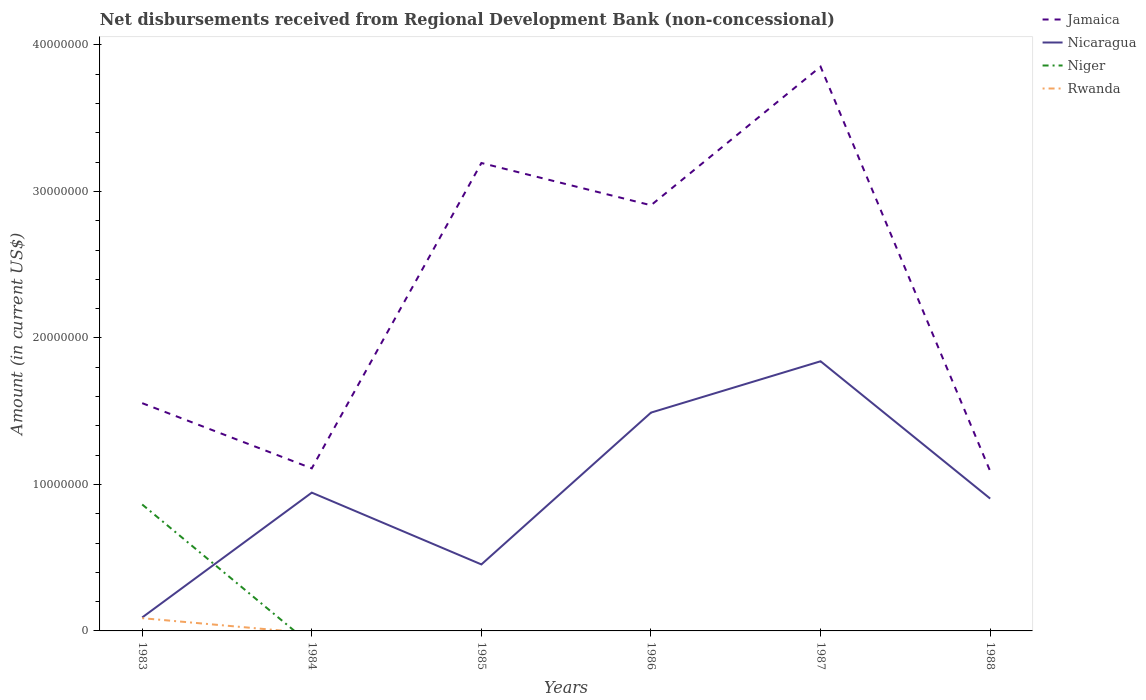Does the line corresponding to Nicaragua intersect with the line corresponding to Rwanda?
Offer a very short reply. No. Across all years, what is the maximum amount of disbursements received from Regional Development Bank in Rwanda?
Provide a succinct answer. 0. What is the total amount of disbursements received from Regional Development Bank in Jamaica in the graph?
Your answer should be compact. -1.35e+07. What is the difference between the highest and the second highest amount of disbursements received from Regional Development Bank in Rwanda?
Give a very brief answer. 8.70e+05. Is the amount of disbursements received from Regional Development Bank in Niger strictly greater than the amount of disbursements received from Regional Development Bank in Nicaragua over the years?
Your answer should be very brief. No. How many lines are there?
Ensure brevity in your answer.  4. Does the graph contain any zero values?
Provide a succinct answer. Yes. Does the graph contain grids?
Your answer should be compact. No. Where does the legend appear in the graph?
Ensure brevity in your answer.  Top right. How are the legend labels stacked?
Offer a terse response. Vertical. What is the title of the graph?
Offer a very short reply. Net disbursements received from Regional Development Bank (non-concessional). Does "Thailand" appear as one of the legend labels in the graph?
Give a very brief answer. No. What is the label or title of the X-axis?
Make the answer very short. Years. What is the label or title of the Y-axis?
Provide a succinct answer. Amount (in current US$). What is the Amount (in current US$) in Jamaica in 1983?
Provide a short and direct response. 1.55e+07. What is the Amount (in current US$) of Nicaragua in 1983?
Offer a very short reply. 9.19e+05. What is the Amount (in current US$) of Niger in 1983?
Offer a very short reply. 8.63e+06. What is the Amount (in current US$) of Rwanda in 1983?
Ensure brevity in your answer.  8.70e+05. What is the Amount (in current US$) in Jamaica in 1984?
Give a very brief answer. 1.11e+07. What is the Amount (in current US$) in Nicaragua in 1984?
Your response must be concise. 9.44e+06. What is the Amount (in current US$) in Rwanda in 1984?
Ensure brevity in your answer.  0. What is the Amount (in current US$) in Jamaica in 1985?
Provide a succinct answer. 3.19e+07. What is the Amount (in current US$) in Nicaragua in 1985?
Your answer should be very brief. 4.54e+06. What is the Amount (in current US$) of Rwanda in 1985?
Provide a succinct answer. 0. What is the Amount (in current US$) of Jamaica in 1986?
Ensure brevity in your answer.  2.91e+07. What is the Amount (in current US$) of Nicaragua in 1986?
Make the answer very short. 1.49e+07. What is the Amount (in current US$) in Jamaica in 1987?
Provide a short and direct response. 3.85e+07. What is the Amount (in current US$) in Nicaragua in 1987?
Your answer should be very brief. 1.84e+07. What is the Amount (in current US$) of Niger in 1987?
Your response must be concise. 0. What is the Amount (in current US$) in Jamaica in 1988?
Offer a very short reply. 1.09e+07. What is the Amount (in current US$) of Nicaragua in 1988?
Your answer should be very brief. 9.03e+06. What is the Amount (in current US$) of Niger in 1988?
Your response must be concise. 0. What is the Amount (in current US$) in Rwanda in 1988?
Provide a short and direct response. 0. Across all years, what is the maximum Amount (in current US$) in Jamaica?
Provide a succinct answer. 3.85e+07. Across all years, what is the maximum Amount (in current US$) of Nicaragua?
Provide a short and direct response. 1.84e+07. Across all years, what is the maximum Amount (in current US$) of Niger?
Keep it short and to the point. 8.63e+06. Across all years, what is the maximum Amount (in current US$) in Rwanda?
Your answer should be very brief. 8.70e+05. Across all years, what is the minimum Amount (in current US$) of Jamaica?
Offer a very short reply. 1.09e+07. Across all years, what is the minimum Amount (in current US$) of Nicaragua?
Offer a terse response. 9.19e+05. Across all years, what is the minimum Amount (in current US$) of Rwanda?
Provide a succinct answer. 0. What is the total Amount (in current US$) in Jamaica in the graph?
Offer a terse response. 1.37e+08. What is the total Amount (in current US$) of Nicaragua in the graph?
Your answer should be very brief. 5.72e+07. What is the total Amount (in current US$) of Niger in the graph?
Offer a terse response. 8.63e+06. What is the total Amount (in current US$) in Rwanda in the graph?
Your response must be concise. 8.70e+05. What is the difference between the Amount (in current US$) of Jamaica in 1983 and that in 1984?
Provide a succinct answer. 4.45e+06. What is the difference between the Amount (in current US$) in Nicaragua in 1983 and that in 1984?
Offer a very short reply. -8.52e+06. What is the difference between the Amount (in current US$) of Jamaica in 1983 and that in 1985?
Make the answer very short. -1.64e+07. What is the difference between the Amount (in current US$) of Nicaragua in 1983 and that in 1985?
Provide a short and direct response. -3.62e+06. What is the difference between the Amount (in current US$) in Jamaica in 1983 and that in 1986?
Give a very brief answer. -1.35e+07. What is the difference between the Amount (in current US$) in Nicaragua in 1983 and that in 1986?
Ensure brevity in your answer.  -1.40e+07. What is the difference between the Amount (in current US$) in Jamaica in 1983 and that in 1987?
Offer a very short reply. -2.30e+07. What is the difference between the Amount (in current US$) of Nicaragua in 1983 and that in 1987?
Your answer should be very brief. -1.75e+07. What is the difference between the Amount (in current US$) in Jamaica in 1983 and that in 1988?
Offer a terse response. 4.64e+06. What is the difference between the Amount (in current US$) in Nicaragua in 1983 and that in 1988?
Your answer should be compact. -8.11e+06. What is the difference between the Amount (in current US$) in Jamaica in 1984 and that in 1985?
Give a very brief answer. -2.08e+07. What is the difference between the Amount (in current US$) in Nicaragua in 1984 and that in 1985?
Your response must be concise. 4.90e+06. What is the difference between the Amount (in current US$) of Jamaica in 1984 and that in 1986?
Provide a short and direct response. -1.80e+07. What is the difference between the Amount (in current US$) of Nicaragua in 1984 and that in 1986?
Keep it short and to the point. -5.46e+06. What is the difference between the Amount (in current US$) of Jamaica in 1984 and that in 1987?
Keep it short and to the point. -2.74e+07. What is the difference between the Amount (in current US$) of Nicaragua in 1984 and that in 1987?
Offer a terse response. -8.97e+06. What is the difference between the Amount (in current US$) in Jamaica in 1984 and that in 1988?
Your answer should be very brief. 1.94e+05. What is the difference between the Amount (in current US$) in Nicaragua in 1984 and that in 1988?
Provide a short and direct response. 4.07e+05. What is the difference between the Amount (in current US$) in Jamaica in 1985 and that in 1986?
Offer a terse response. 2.88e+06. What is the difference between the Amount (in current US$) in Nicaragua in 1985 and that in 1986?
Your answer should be very brief. -1.04e+07. What is the difference between the Amount (in current US$) in Jamaica in 1985 and that in 1987?
Make the answer very short. -6.58e+06. What is the difference between the Amount (in current US$) of Nicaragua in 1985 and that in 1987?
Give a very brief answer. -1.39e+07. What is the difference between the Amount (in current US$) in Jamaica in 1985 and that in 1988?
Provide a succinct answer. 2.10e+07. What is the difference between the Amount (in current US$) in Nicaragua in 1985 and that in 1988?
Offer a terse response. -4.49e+06. What is the difference between the Amount (in current US$) in Jamaica in 1986 and that in 1987?
Provide a short and direct response. -9.46e+06. What is the difference between the Amount (in current US$) in Nicaragua in 1986 and that in 1987?
Make the answer very short. -3.50e+06. What is the difference between the Amount (in current US$) in Jamaica in 1986 and that in 1988?
Give a very brief answer. 1.82e+07. What is the difference between the Amount (in current US$) in Nicaragua in 1986 and that in 1988?
Provide a succinct answer. 5.87e+06. What is the difference between the Amount (in current US$) in Jamaica in 1987 and that in 1988?
Your response must be concise. 2.76e+07. What is the difference between the Amount (in current US$) in Nicaragua in 1987 and that in 1988?
Offer a very short reply. 9.37e+06. What is the difference between the Amount (in current US$) in Jamaica in 1983 and the Amount (in current US$) in Nicaragua in 1984?
Provide a succinct answer. 6.11e+06. What is the difference between the Amount (in current US$) of Jamaica in 1983 and the Amount (in current US$) of Nicaragua in 1985?
Offer a terse response. 1.10e+07. What is the difference between the Amount (in current US$) in Jamaica in 1983 and the Amount (in current US$) in Nicaragua in 1986?
Keep it short and to the point. 6.45e+05. What is the difference between the Amount (in current US$) in Jamaica in 1983 and the Amount (in current US$) in Nicaragua in 1987?
Ensure brevity in your answer.  -2.86e+06. What is the difference between the Amount (in current US$) of Jamaica in 1983 and the Amount (in current US$) of Nicaragua in 1988?
Your response must be concise. 6.51e+06. What is the difference between the Amount (in current US$) in Jamaica in 1984 and the Amount (in current US$) in Nicaragua in 1985?
Offer a terse response. 6.56e+06. What is the difference between the Amount (in current US$) in Jamaica in 1984 and the Amount (in current US$) in Nicaragua in 1986?
Offer a terse response. -3.80e+06. What is the difference between the Amount (in current US$) in Jamaica in 1984 and the Amount (in current US$) in Nicaragua in 1987?
Your answer should be compact. -7.31e+06. What is the difference between the Amount (in current US$) in Jamaica in 1984 and the Amount (in current US$) in Nicaragua in 1988?
Your response must be concise. 2.06e+06. What is the difference between the Amount (in current US$) of Jamaica in 1985 and the Amount (in current US$) of Nicaragua in 1986?
Make the answer very short. 1.70e+07. What is the difference between the Amount (in current US$) of Jamaica in 1985 and the Amount (in current US$) of Nicaragua in 1987?
Keep it short and to the point. 1.35e+07. What is the difference between the Amount (in current US$) in Jamaica in 1985 and the Amount (in current US$) in Nicaragua in 1988?
Give a very brief answer. 2.29e+07. What is the difference between the Amount (in current US$) of Jamaica in 1986 and the Amount (in current US$) of Nicaragua in 1987?
Your response must be concise. 1.06e+07. What is the difference between the Amount (in current US$) in Jamaica in 1986 and the Amount (in current US$) in Nicaragua in 1988?
Your answer should be very brief. 2.00e+07. What is the difference between the Amount (in current US$) in Jamaica in 1987 and the Amount (in current US$) in Nicaragua in 1988?
Provide a succinct answer. 2.95e+07. What is the average Amount (in current US$) in Jamaica per year?
Provide a succinct answer. 2.28e+07. What is the average Amount (in current US$) in Nicaragua per year?
Your response must be concise. 9.54e+06. What is the average Amount (in current US$) of Niger per year?
Provide a short and direct response. 1.44e+06. What is the average Amount (in current US$) in Rwanda per year?
Provide a short and direct response. 1.45e+05. In the year 1983, what is the difference between the Amount (in current US$) of Jamaica and Amount (in current US$) of Nicaragua?
Your answer should be very brief. 1.46e+07. In the year 1983, what is the difference between the Amount (in current US$) of Jamaica and Amount (in current US$) of Niger?
Give a very brief answer. 6.92e+06. In the year 1983, what is the difference between the Amount (in current US$) in Jamaica and Amount (in current US$) in Rwanda?
Your answer should be very brief. 1.47e+07. In the year 1983, what is the difference between the Amount (in current US$) in Nicaragua and Amount (in current US$) in Niger?
Provide a short and direct response. -7.71e+06. In the year 1983, what is the difference between the Amount (in current US$) in Nicaragua and Amount (in current US$) in Rwanda?
Your answer should be compact. 4.90e+04. In the year 1983, what is the difference between the Amount (in current US$) in Niger and Amount (in current US$) in Rwanda?
Keep it short and to the point. 7.76e+06. In the year 1984, what is the difference between the Amount (in current US$) in Jamaica and Amount (in current US$) in Nicaragua?
Provide a succinct answer. 1.66e+06. In the year 1985, what is the difference between the Amount (in current US$) of Jamaica and Amount (in current US$) of Nicaragua?
Your response must be concise. 2.74e+07. In the year 1986, what is the difference between the Amount (in current US$) of Jamaica and Amount (in current US$) of Nicaragua?
Offer a terse response. 1.42e+07. In the year 1987, what is the difference between the Amount (in current US$) of Jamaica and Amount (in current US$) of Nicaragua?
Provide a short and direct response. 2.01e+07. In the year 1988, what is the difference between the Amount (in current US$) of Jamaica and Amount (in current US$) of Nicaragua?
Keep it short and to the point. 1.87e+06. What is the ratio of the Amount (in current US$) in Jamaica in 1983 to that in 1984?
Offer a terse response. 1.4. What is the ratio of the Amount (in current US$) of Nicaragua in 1983 to that in 1984?
Keep it short and to the point. 0.1. What is the ratio of the Amount (in current US$) of Jamaica in 1983 to that in 1985?
Your answer should be compact. 0.49. What is the ratio of the Amount (in current US$) of Nicaragua in 1983 to that in 1985?
Keep it short and to the point. 0.2. What is the ratio of the Amount (in current US$) of Jamaica in 1983 to that in 1986?
Provide a short and direct response. 0.54. What is the ratio of the Amount (in current US$) in Nicaragua in 1983 to that in 1986?
Your response must be concise. 0.06. What is the ratio of the Amount (in current US$) of Jamaica in 1983 to that in 1987?
Offer a very short reply. 0.4. What is the ratio of the Amount (in current US$) in Nicaragua in 1983 to that in 1987?
Offer a terse response. 0.05. What is the ratio of the Amount (in current US$) of Jamaica in 1983 to that in 1988?
Your answer should be compact. 1.43. What is the ratio of the Amount (in current US$) in Nicaragua in 1983 to that in 1988?
Offer a very short reply. 0.1. What is the ratio of the Amount (in current US$) in Jamaica in 1984 to that in 1985?
Make the answer very short. 0.35. What is the ratio of the Amount (in current US$) of Nicaragua in 1984 to that in 1985?
Keep it short and to the point. 2.08. What is the ratio of the Amount (in current US$) in Jamaica in 1984 to that in 1986?
Your answer should be compact. 0.38. What is the ratio of the Amount (in current US$) of Nicaragua in 1984 to that in 1986?
Ensure brevity in your answer.  0.63. What is the ratio of the Amount (in current US$) of Jamaica in 1984 to that in 1987?
Keep it short and to the point. 0.29. What is the ratio of the Amount (in current US$) in Nicaragua in 1984 to that in 1987?
Your answer should be compact. 0.51. What is the ratio of the Amount (in current US$) of Jamaica in 1984 to that in 1988?
Offer a very short reply. 1.02. What is the ratio of the Amount (in current US$) of Nicaragua in 1984 to that in 1988?
Your answer should be compact. 1.05. What is the ratio of the Amount (in current US$) of Jamaica in 1985 to that in 1986?
Your answer should be very brief. 1.1. What is the ratio of the Amount (in current US$) in Nicaragua in 1985 to that in 1986?
Provide a succinct answer. 0.3. What is the ratio of the Amount (in current US$) in Jamaica in 1985 to that in 1987?
Your response must be concise. 0.83. What is the ratio of the Amount (in current US$) in Nicaragua in 1985 to that in 1987?
Your answer should be compact. 0.25. What is the ratio of the Amount (in current US$) in Jamaica in 1985 to that in 1988?
Provide a succinct answer. 2.93. What is the ratio of the Amount (in current US$) in Nicaragua in 1985 to that in 1988?
Give a very brief answer. 0.5. What is the ratio of the Amount (in current US$) in Jamaica in 1986 to that in 1987?
Give a very brief answer. 0.75. What is the ratio of the Amount (in current US$) of Nicaragua in 1986 to that in 1987?
Offer a very short reply. 0.81. What is the ratio of the Amount (in current US$) of Jamaica in 1986 to that in 1988?
Your response must be concise. 2.66. What is the ratio of the Amount (in current US$) in Nicaragua in 1986 to that in 1988?
Keep it short and to the point. 1.65. What is the ratio of the Amount (in current US$) of Jamaica in 1987 to that in 1988?
Your answer should be very brief. 3.53. What is the ratio of the Amount (in current US$) of Nicaragua in 1987 to that in 1988?
Your response must be concise. 2.04. What is the difference between the highest and the second highest Amount (in current US$) of Jamaica?
Offer a very short reply. 6.58e+06. What is the difference between the highest and the second highest Amount (in current US$) of Nicaragua?
Keep it short and to the point. 3.50e+06. What is the difference between the highest and the lowest Amount (in current US$) of Jamaica?
Make the answer very short. 2.76e+07. What is the difference between the highest and the lowest Amount (in current US$) in Nicaragua?
Offer a terse response. 1.75e+07. What is the difference between the highest and the lowest Amount (in current US$) in Niger?
Provide a succinct answer. 8.63e+06. What is the difference between the highest and the lowest Amount (in current US$) in Rwanda?
Provide a succinct answer. 8.70e+05. 